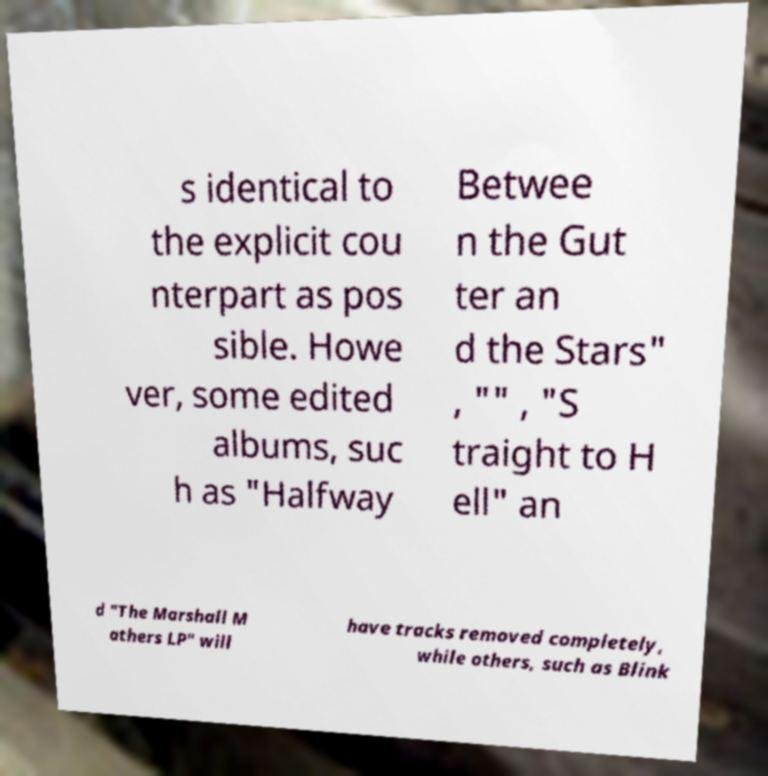Please read and relay the text visible in this image. What does it say? s identical to the explicit cou nterpart as pos sible. Howe ver, some edited albums, suc h as "Halfway Betwee n the Gut ter an d the Stars" , "" , "S traight to H ell" an d "The Marshall M athers LP" will have tracks removed completely, while others, such as Blink 